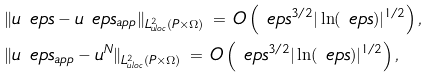<formula> <loc_0><loc_0><loc_500><loc_500>& \| u ^ { \ } e p s - u ^ { \ } e p s _ { a p p } \| _ { L ^ { 2 } _ { u l o c } ( P \times \Omega ) } \, = \, O \left ( \ e p s ^ { 3 / 2 } | \ln ( \ e p s ) | ^ { 1 / 2 } \right ) , \\ & \| u ^ { \ } e p s _ { a p p } - u ^ { N } \| _ { L ^ { 2 } _ { u l o c } ( P \times \Omega ) } \, = \, O \left ( \ e p s ^ { 3 / 2 } | \ln ( \ e p s ) | ^ { 1 / 2 } \right ) ,</formula> 